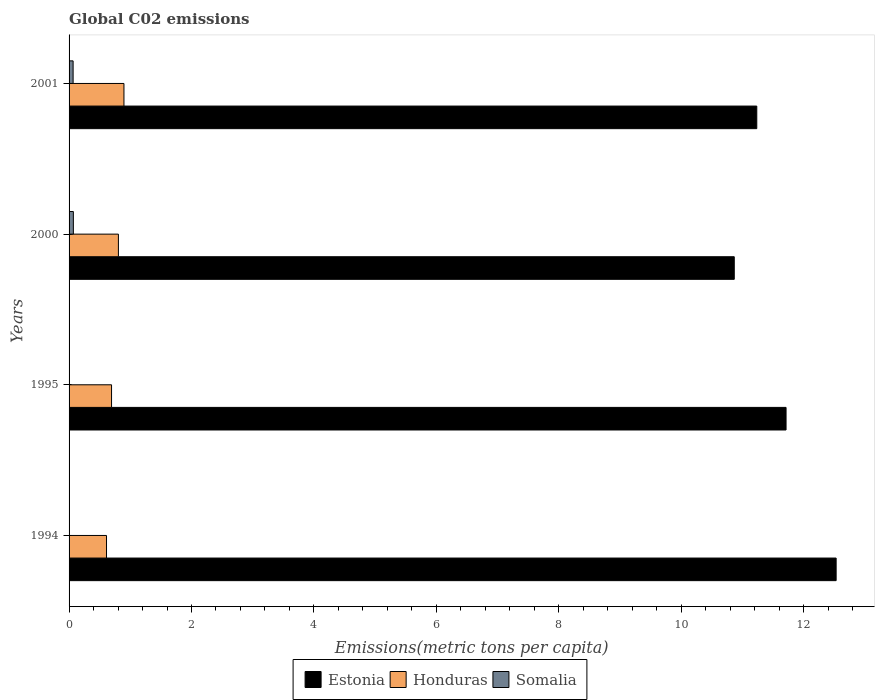How many bars are there on the 3rd tick from the top?
Make the answer very short. 3. What is the label of the 1st group of bars from the top?
Provide a succinct answer. 2001. In how many cases, is the number of bars for a given year not equal to the number of legend labels?
Provide a short and direct response. 0. What is the amount of CO2 emitted in in Estonia in 1994?
Your answer should be compact. 12.53. Across all years, what is the maximum amount of CO2 emitted in in Somalia?
Provide a succinct answer. 0.07. Across all years, what is the minimum amount of CO2 emitted in in Somalia?
Give a very brief answer. 0. What is the total amount of CO2 emitted in in Somalia in the graph?
Provide a short and direct response. 0.14. What is the difference between the amount of CO2 emitted in in Estonia in 1994 and that in 1995?
Keep it short and to the point. 0.82. What is the difference between the amount of CO2 emitted in in Estonia in 1994 and the amount of CO2 emitted in in Honduras in 2001?
Ensure brevity in your answer.  11.63. What is the average amount of CO2 emitted in in Estonia per year?
Offer a very short reply. 11.59. In the year 1994, what is the difference between the amount of CO2 emitted in in Somalia and amount of CO2 emitted in in Honduras?
Offer a terse response. -0.61. What is the ratio of the amount of CO2 emitted in in Honduras in 1994 to that in 2000?
Ensure brevity in your answer.  0.76. What is the difference between the highest and the second highest amount of CO2 emitted in in Estonia?
Ensure brevity in your answer.  0.82. What is the difference between the highest and the lowest amount of CO2 emitted in in Estonia?
Offer a very short reply. 1.66. What does the 1st bar from the top in 1994 represents?
Ensure brevity in your answer.  Somalia. What does the 3rd bar from the bottom in 1994 represents?
Offer a terse response. Somalia. Is it the case that in every year, the sum of the amount of CO2 emitted in in Somalia and amount of CO2 emitted in in Honduras is greater than the amount of CO2 emitted in in Estonia?
Your response must be concise. No. How many bars are there?
Ensure brevity in your answer.  12. Are all the bars in the graph horizontal?
Give a very brief answer. Yes. How many years are there in the graph?
Your response must be concise. 4. Does the graph contain any zero values?
Your response must be concise. No. How many legend labels are there?
Offer a very short reply. 3. How are the legend labels stacked?
Make the answer very short. Horizontal. What is the title of the graph?
Keep it short and to the point. Global C02 emissions. What is the label or title of the X-axis?
Make the answer very short. Emissions(metric tons per capita). What is the Emissions(metric tons per capita) of Estonia in 1994?
Make the answer very short. 12.53. What is the Emissions(metric tons per capita) in Honduras in 1994?
Give a very brief answer. 0.61. What is the Emissions(metric tons per capita) in Somalia in 1994?
Your answer should be compact. 0. What is the Emissions(metric tons per capita) of Estonia in 1995?
Your answer should be very brief. 11.71. What is the Emissions(metric tons per capita) in Honduras in 1995?
Provide a succinct answer. 0.69. What is the Emissions(metric tons per capita) of Somalia in 1995?
Make the answer very short. 0. What is the Emissions(metric tons per capita) of Estonia in 2000?
Ensure brevity in your answer.  10.87. What is the Emissions(metric tons per capita) of Honduras in 2000?
Make the answer very short. 0.81. What is the Emissions(metric tons per capita) of Somalia in 2000?
Your answer should be compact. 0.07. What is the Emissions(metric tons per capita) of Estonia in 2001?
Make the answer very short. 11.24. What is the Emissions(metric tons per capita) in Honduras in 2001?
Give a very brief answer. 0.9. What is the Emissions(metric tons per capita) of Somalia in 2001?
Give a very brief answer. 0.07. Across all years, what is the maximum Emissions(metric tons per capita) in Estonia?
Provide a succinct answer. 12.53. Across all years, what is the maximum Emissions(metric tons per capita) of Honduras?
Make the answer very short. 0.9. Across all years, what is the maximum Emissions(metric tons per capita) in Somalia?
Offer a terse response. 0.07. Across all years, what is the minimum Emissions(metric tons per capita) of Estonia?
Provide a short and direct response. 10.87. Across all years, what is the minimum Emissions(metric tons per capita) of Honduras?
Provide a succinct answer. 0.61. Across all years, what is the minimum Emissions(metric tons per capita) of Somalia?
Make the answer very short. 0. What is the total Emissions(metric tons per capita) of Estonia in the graph?
Your answer should be compact. 46.35. What is the total Emissions(metric tons per capita) of Honduras in the graph?
Make the answer very short. 3.01. What is the total Emissions(metric tons per capita) of Somalia in the graph?
Provide a succinct answer. 0.14. What is the difference between the Emissions(metric tons per capita) of Estonia in 1994 and that in 1995?
Offer a terse response. 0.82. What is the difference between the Emissions(metric tons per capita) in Honduras in 1994 and that in 1995?
Provide a succinct answer. -0.08. What is the difference between the Emissions(metric tons per capita) in Estonia in 1994 and that in 2000?
Keep it short and to the point. 1.66. What is the difference between the Emissions(metric tons per capita) of Honduras in 1994 and that in 2000?
Your answer should be compact. -0.19. What is the difference between the Emissions(metric tons per capita) in Somalia in 1994 and that in 2000?
Provide a succinct answer. -0.07. What is the difference between the Emissions(metric tons per capita) in Estonia in 1994 and that in 2001?
Your response must be concise. 1.3. What is the difference between the Emissions(metric tons per capita) in Honduras in 1994 and that in 2001?
Make the answer very short. -0.28. What is the difference between the Emissions(metric tons per capita) in Somalia in 1994 and that in 2001?
Offer a very short reply. -0.06. What is the difference between the Emissions(metric tons per capita) in Estonia in 1995 and that in 2000?
Provide a succinct answer. 0.85. What is the difference between the Emissions(metric tons per capita) in Honduras in 1995 and that in 2000?
Your answer should be compact. -0.11. What is the difference between the Emissions(metric tons per capita) of Somalia in 1995 and that in 2000?
Give a very brief answer. -0.07. What is the difference between the Emissions(metric tons per capita) of Estonia in 1995 and that in 2001?
Give a very brief answer. 0.48. What is the difference between the Emissions(metric tons per capita) of Honduras in 1995 and that in 2001?
Make the answer very short. -0.2. What is the difference between the Emissions(metric tons per capita) in Somalia in 1995 and that in 2001?
Your response must be concise. -0.06. What is the difference between the Emissions(metric tons per capita) in Estonia in 2000 and that in 2001?
Ensure brevity in your answer.  -0.37. What is the difference between the Emissions(metric tons per capita) of Honduras in 2000 and that in 2001?
Your answer should be very brief. -0.09. What is the difference between the Emissions(metric tons per capita) of Somalia in 2000 and that in 2001?
Provide a succinct answer. 0. What is the difference between the Emissions(metric tons per capita) in Estonia in 1994 and the Emissions(metric tons per capita) in Honduras in 1995?
Offer a terse response. 11.84. What is the difference between the Emissions(metric tons per capita) in Estonia in 1994 and the Emissions(metric tons per capita) in Somalia in 1995?
Your answer should be compact. 12.53. What is the difference between the Emissions(metric tons per capita) of Honduras in 1994 and the Emissions(metric tons per capita) of Somalia in 1995?
Your answer should be very brief. 0.61. What is the difference between the Emissions(metric tons per capita) in Estonia in 1994 and the Emissions(metric tons per capita) in Honduras in 2000?
Ensure brevity in your answer.  11.73. What is the difference between the Emissions(metric tons per capita) of Estonia in 1994 and the Emissions(metric tons per capita) of Somalia in 2000?
Make the answer very short. 12.46. What is the difference between the Emissions(metric tons per capita) in Honduras in 1994 and the Emissions(metric tons per capita) in Somalia in 2000?
Make the answer very short. 0.54. What is the difference between the Emissions(metric tons per capita) of Estonia in 1994 and the Emissions(metric tons per capita) of Honduras in 2001?
Ensure brevity in your answer.  11.63. What is the difference between the Emissions(metric tons per capita) in Estonia in 1994 and the Emissions(metric tons per capita) in Somalia in 2001?
Make the answer very short. 12.47. What is the difference between the Emissions(metric tons per capita) in Honduras in 1994 and the Emissions(metric tons per capita) in Somalia in 2001?
Offer a very short reply. 0.55. What is the difference between the Emissions(metric tons per capita) of Estonia in 1995 and the Emissions(metric tons per capita) of Honduras in 2000?
Offer a very short reply. 10.91. What is the difference between the Emissions(metric tons per capita) of Estonia in 1995 and the Emissions(metric tons per capita) of Somalia in 2000?
Provide a succinct answer. 11.64. What is the difference between the Emissions(metric tons per capita) of Honduras in 1995 and the Emissions(metric tons per capita) of Somalia in 2000?
Keep it short and to the point. 0.62. What is the difference between the Emissions(metric tons per capita) in Estonia in 1995 and the Emissions(metric tons per capita) in Honduras in 2001?
Provide a short and direct response. 10.82. What is the difference between the Emissions(metric tons per capita) in Estonia in 1995 and the Emissions(metric tons per capita) in Somalia in 2001?
Provide a succinct answer. 11.65. What is the difference between the Emissions(metric tons per capita) in Honduras in 1995 and the Emissions(metric tons per capita) in Somalia in 2001?
Give a very brief answer. 0.63. What is the difference between the Emissions(metric tons per capita) in Estonia in 2000 and the Emissions(metric tons per capita) in Honduras in 2001?
Provide a succinct answer. 9.97. What is the difference between the Emissions(metric tons per capita) of Estonia in 2000 and the Emissions(metric tons per capita) of Somalia in 2001?
Ensure brevity in your answer.  10.8. What is the difference between the Emissions(metric tons per capita) in Honduras in 2000 and the Emissions(metric tons per capita) in Somalia in 2001?
Offer a terse response. 0.74. What is the average Emissions(metric tons per capita) of Estonia per year?
Offer a very short reply. 11.59. What is the average Emissions(metric tons per capita) of Honduras per year?
Keep it short and to the point. 0.75. What is the average Emissions(metric tons per capita) of Somalia per year?
Your answer should be compact. 0.03. In the year 1994, what is the difference between the Emissions(metric tons per capita) in Estonia and Emissions(metric tons per capita) in Honduras?
Provide a short and direct response. 11.92. In the year 1994, what is the difference between the Emissions(metric tons per capita) in Estonia and Emissions(metric tons per capita) in Somalia?
Make the answer very short. 12.53. In the year 1994, what is the difference between the Emissions(metric tons per capita) in Honduras and Emissions(metric tons per capita) in Somalia?
Give a very brief answer. 0.61. In the year 1995, what is the difference between the Emissions(metric tons per capita) in Estonia and Emissions(metric tons per capita) in Honduras?
Provide a succinct answer. 11.02. In the year 1995, what is the difference between the Emissions(metric tons per capita) in Estonia and Emissions(metric tons per capita) in Somalia?
Keep it short and to the point. 11.71. In the year 1995, what is the difference between the Emissions(metric tons per capita) of Honduras and Emissions(metric tons per capita) of Somalia?
Offer a terse response. 0.69. In the year 2000, what is the difference between the Emissions(metric tons per capita) of Estonia and Emissions(metric tons per capita) of Honduras?
Keep it short and to the point. 10.06. In the year 2000, what is the difference between the Emissions(metric tons per capita) in Estonia and Emissions(metric tons per capita) in Somalia?
Provide a short and direct response. 10.8. In the year 2000, what is the difference between the Emissions(metric tons per capita) of Honduras and Emissions(metric tons per capita) of Somalia?
Provide a succinct answer. 0.74. In the year 2001, what is the difference between the Emissions(metric tons per capita) of Estonia and Emissions(metric tons per capita) of Honduras?
Give a very brief answer. 10.34. In the year 2001, what is the difference between the Emissions(metric tons per capita) of Estonia and Emissions(metric tons per capita) of Somalia?
Ensure brevity in your answer.  11.17. In the year 2001, what is the difference between the Emissions(metric tons per capita) in Honduras and Emissions(metric tons per capita) in Somalia?
Make the answer very short. 0.83. What is the ratio of the Emissions(metric tons per capita) of Estonia in 1994 to that in 1995?
Ensure brevity in your answer.  1.07. What is the ratio of the Emissions(metric tons per capita) in Honduras in 1994 to that in 1995?
Your response must be concise. 0.88. What is the ratio of the Emissions(metric tons per capita) of Somalia in 1994 to that in 1995?
Your answer should be very brief. 1.01. What is the ratio of the Emissions(metric tons per capita) in Estonia in 1994 to that in 2000?
Ensure brevity in your answer.  1.15. What is the ratio of the Emissions(metric tons per capita) in Honduras in 1994 to that in 2000?
Give a very brief answer. 0.76. What is the ratio of the Emissions(metric tons per capita) of Somalia in 1994 to that in 2000?
Your answer should be very brief. 0.03. What is the ratio of the Emissions(metric tons per capita) of Estonia in 1994 to that in 2001?
Provide a succinct answer. 1.12. What is the ratio of the Emissions(metric tons per capita) in Honduras in 1994 to that in 2001?
Keep it short and to the point. 0.68. What is the ratio of the Emissions(metric tons per capita) of Somalia in 1994 to that in 2001?
Provide a succinct answer. 0.03. What is the ratio of the Emissions(metric tons per capita) in Estonia in 1995 to that in 2000?
Make the answer very short. 1.08. What is the ratio of the Emissions(metric tons per capita) of Honduras in 1995 to that in 2000?
Your answer should be compact. 0.86. What is the ratio of the Emissions(metric tons per capita) of Somalia in 1995 to that in 2000?
Make the answer very short. 0.02. What is the ratio of the Emissions(metric tons per capita) in Estonia in 1995 to that in 2001?
Provide a short and direct response. 1.04. What is the ratio of the Emissions(metric tons per capita) in Honduras in 1995 to that in 2001?
Ensure brevity in your answer.  0.77. What is the ratio of the Emissions(metric tons per capita) in Somalia in 1995 to that in 2001?
Provide a short and direct response. 0.03. What is the ratio of the Emissions(metric tons per capita) of Estonia in 2000 to that in 2001?
Give a very brief answer. 0.97. What is the ratio of the Emissions(metric tons per capita) in Honduras in 2000 to that in 2001?
Offer a terse response. 0.9. What is the ratio of the Emissions(metric tons per capita) of Somalia in 2000 to that in 2001?
Your response must be concise. 1.06. What is the difference between the highest and the second highest Emissions(metric tons per capita) of Estonia?
Give a very brief answer. 0.82. What is the difference between the highest and the second highest Emissions(metric tons per capita) in Honduras?
Offer a very short reply. 0.09. What is the difference between the highest and the second highest Emissions(metric tons per capita) of Somalia?
Offer a very short reply. 0. What is the difference between the highest and the lowest Emissions(metric tons per capita) of Estonia?
Keep it short and to the point. 1.66. What is the difference between the highest and the lowest Emissions(metric tons per capita) of Honduras?
Your response must be concise. 0.28. What is the difference between the highest and the lowest Emissions(metric tons per capita) in Somalia?
Provide a short and direct response. 0.07. 